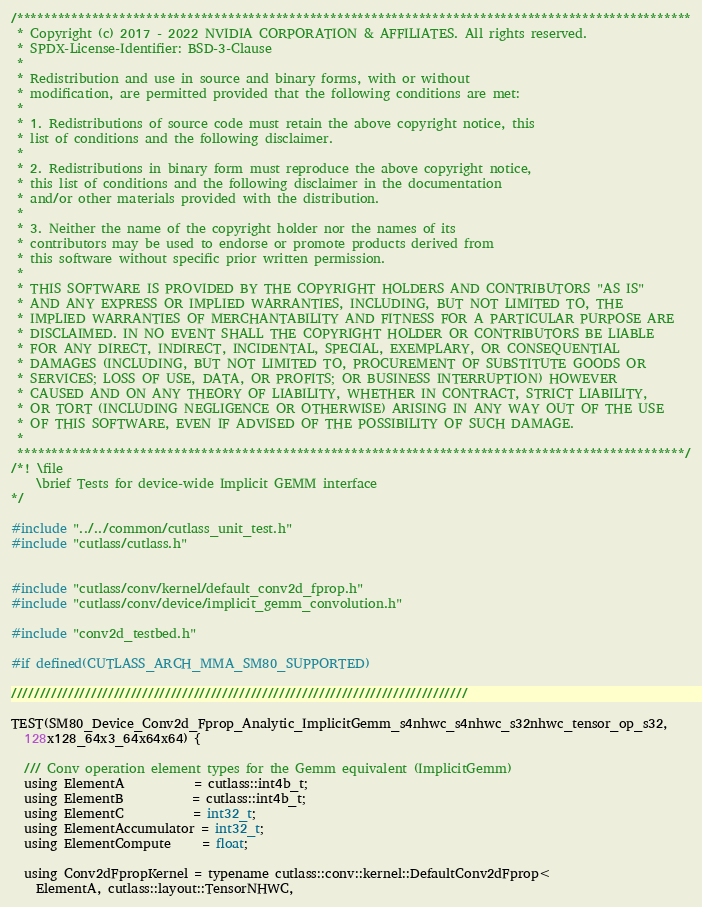<code> <loc_0><loc_0><loc_500><loc_500><_Cuda_>/***************************************************************************************************
 * Copyright (c) 2017 - 2022 NVIDIA CORPORATION & AFFILIATES. All rights reserved.
 * SPDX-License-Identifier: BSD-3-Clause
 *
 * Redistribution and use in source and binary forms, with or without
 * modification, are permitted provided that the following conditions are met:
 *
 * 1. Redistributions of source code must retain the above copyright notice, this
 * list of conditions and the following disclaimer.
 *
 * 2. Redistributions in binary form must reproduce the above copyright notice,
 * this list of conditions and the following disclaimer in the documentation
 * and/or other materials provided with the distribution.
 *
 * 3. Neither the name of the copyright holder nor the names of its
 * contributors may be used to endorse or promote products derived from
 * this software without specific prior written permission.
 *
 * THIS SOFTWARE IS PROVIDED BY THE COPYRIGHT HOLDERS AND CONTRIBUTORS "AS IS"
 * AND ANY EXPRESS OR IMPLIED WARRANTIES, INCLUDING, BUT NOT LIMITED TO, THE
 * IMPLIED WARRANTIES OF MERCHANTABILITY AND FITNESS FOR A PARTICULAR PURPOSE ARE
 * DISCLAIMED. IN NO EVENT SHALL THE COPYRIGHT HOLDER OR CONTRIBUTORS BE LIABLE
 * FOR ANY DIRECT, INDIRECT, INCIDENTAL, SPECIAL, EXEMPLARY, OR CONSEQUENTIAL
 * DAMAGES (INCLUDING, BUT NOT LIMITED TO, PROCUREMENT OF SUBSTITUTE GOODS OR
 * SERVICES; LOSS OF USE, DATA, OR PROFITS; OR BUSINESS INTERRUPTION) HOWEVER
 * CAUSED AND ON ANY THEORY OF LIABILITY, WHETHER IN CONTRACT, STRICT LIABILITY,
 * OR TORT (INCLUDING NEGLIGENCE OR OTHERWISE) ARISING IN ANY WAY OUT OF THE USE
 * OF THIS SOFTWARE, EVEN IF ADVISED OF THE POSSIBILITY OF SUCH DAMAGE.
 *
 **************************************************************************************************/
/*! \file
    \brief Tests for device-wide Implicit GEMM interface
*/

#include "../../common/cutlass_unit_test.h"
#include "cutlass/cutlass.h"


#include "cutlass/conv/kernel/default_conv2d_fprop.h"
#include "cutlass/conv/device/implicit_gemm_convolution.h"

#include "conv2d_testbed.h"

#if defined(CUTLASS_ARCH_MMA_SM80_SUPPORTED)

////////////////////////////////////////////////////////////////////////////////
    
TEST(SM80_Device_Conv2d_Fprop_Analytic_ImplicitGemm_s4nhwc_s4nhwc_s32nhwc_tensor_op_s32,
  128x128_64x3_64x64x64) {

  /// Conv operation element types for the Gemm equivalent (ImplicitGemm)
  using ElementA           = cutlass::int4b_t;
  using ElementB           = cutlass::int4b_t;
  using ElementC           = int32_t;
  using ElementAccumulator = int32_t;
  using ElementCompute     = float;

  using Conv2dFpropKernel = typename cutlass::conv::kernel::DefaultConv2dFprop<
    ElementA, cutlass::layout::TensorNHWC,</code> 